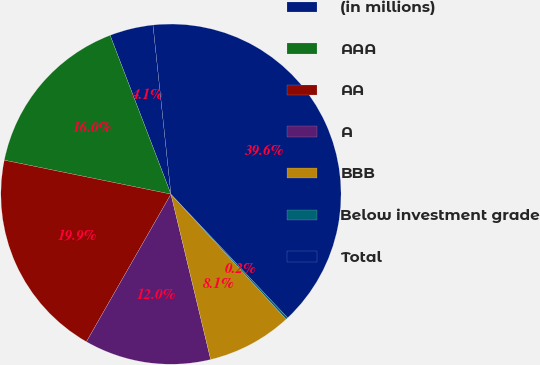<chart> <loc_0><loc_0><loc_500><loc_500><pie_chart><fcel>(in millions)<fcel>AAA<fcel>AA<fcel>A<fcel>BBB<fcel>Below investment grade<fcel>Total<nl><fcel>4.14%<fcel>15.98%<fcel>19.92%<fcel>12.03%<fcel>8.09%<fcel>0.2%<fcel>39.64%<nl></chart> 